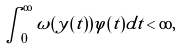Convert formula to latex. <formula><loc_0><loc_0><loc_500><loc_500>\int _ { 0 } ^ { \infty } \omega ( y ( t ) ) \varphi ( t ) d t < \infty ,</formula> 